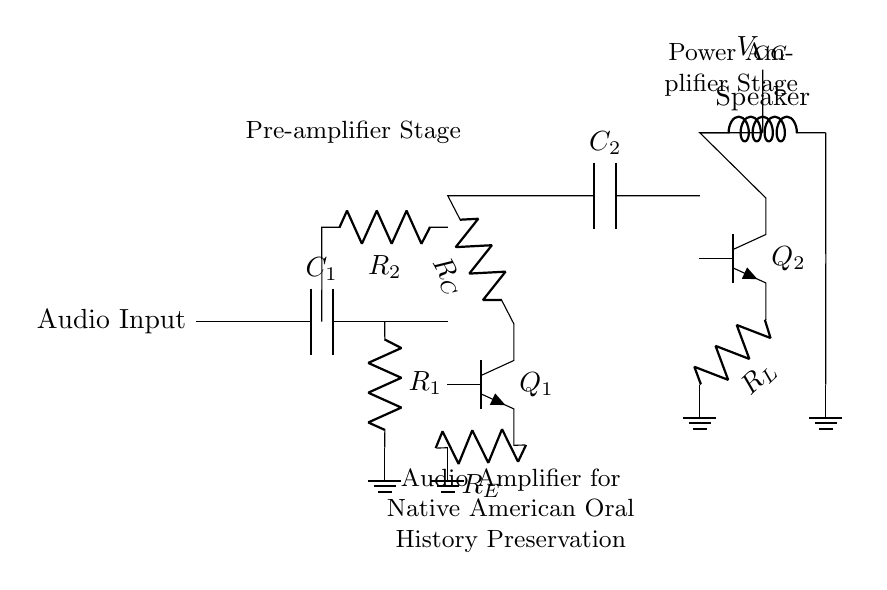What is the function of C1 in the circuit? C1 is a coupling capacitor that allows AC signals to pass while blocking DC, protecting subsequent stages from unwanted DC bias.
Answer: Coupling capacitor What type of transistors are used in the amplifier? The circuit uses npn transistors, indicated by the npn notation next to the components labeled Q1 and Q2.
Answer: Npn What is the main purpose of this audio amplifier circuit? The primary purpose of this circuit is to amplify audio signals to preserve and enhance Native American oral history recordings.
Answer: Audio amplification How many resistors are present in the pre-amplifier stage? In the pre-amplifier stage, there are three resistors labeled R1, R2, and RE; therefore, the total count is three resistors.
Answer: Three resistors What is the role of R_L in the circuit? R_L is the load resistor which works in the power amplifier stage to help drive the speaker by converting the output current from the transistor into a usable audio signal.
Answer: Load resistor What would happen if C2 were removed from the circuit? Removing C2 would prevent the audio signal from being coupled to the power amplifier stage; thus, no audio would be transmitted to the speaker.
Answer: No audio transmission What component connects the audio input to the first stage of the amplifier? The component connecting the audio input to the first stage is the coupling capacitor C1, which allows the input audio signal to pass to the pre-amplifier.
Answer: Coupling capacitor C1 